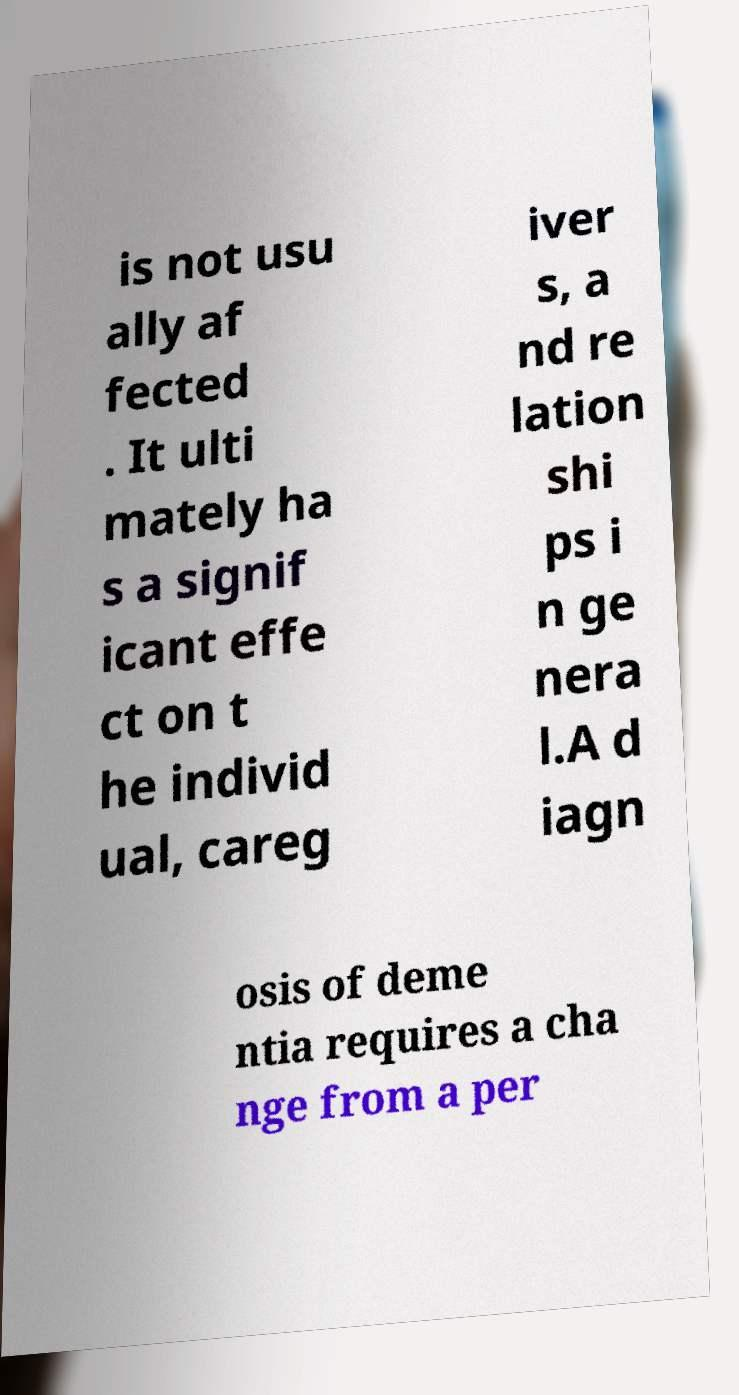Could you assist in decoding the text presented in this image and type it out clearly? is not usu ally af fected . It ulti mately ha s a signif icant effe ct on t he individ ual, careg iver s, a nd re lation shi ps i n ge nera l.A d iagn osis of deme ntia requires a cha nge from a per 